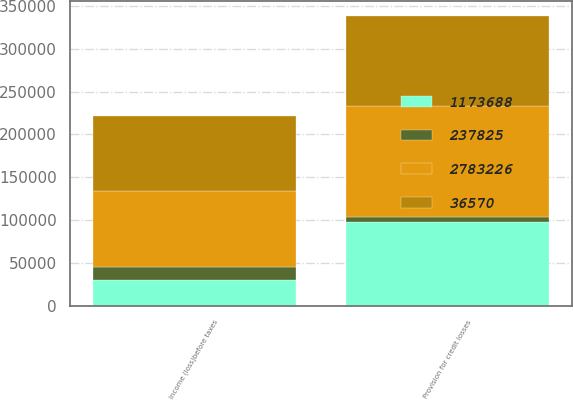<chart> <loc_0><loc_0><loc_500><loc_500><stacked_bar_chart><ecel><fcel>Provision for credit losses<fcel>Income (loss)before taxes<nl><fcel>1.17369e+06<fcel>97816<fcel>29673<nl><fcel>36570<fcel>104995<fcel>87938<nl><fcel>237825<fcel>5302<fcel>15986<nl><fcel>2.78323e+06<fcel>130509<fcel>87938<nl></chart> 